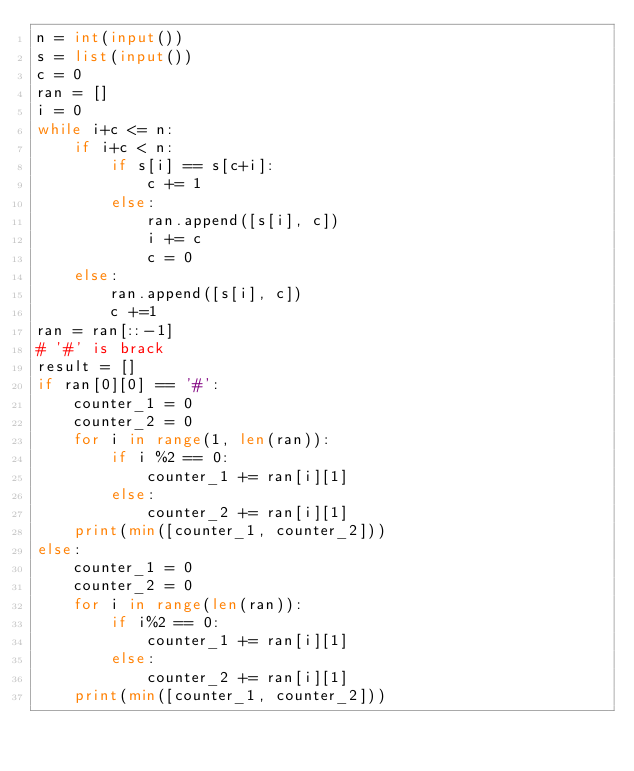Convert code to text. <code><loc_0><loc_0><loc_500><loc_500><_Python_>n = int(input())
s = list(input())
c = 0
ran = []
i = 0
while i+c <= n:
    if i+c < n:
        if s[i] == s[c+i]:
            c += 1
        else:
            ran.append([s[i], c])
            i += c
            c = 0
    else:
        ran.append([s[i], c])
        c +=1
ran = ran[::-1]
# '#' is brack
result = []
if ran[0][0] == '#':
    counter_1 = 0
    counter_2 = 0
    for i in range(1, len(ran)):
        if i %2 == 0:
            counter_1 += ran[i][1]
        else:
            counter_2 += ran[i][1]
    print(min([counter_1, counter_2]))
else:
    counter_1 = 0
    counter_2 = 0
    for i in range(len(ran)):
        if i%2 == 0:
            counter_1 += ran[i][1]
        else:
            counter_2 += ran[i][1]
    print(min([counter_1, counter_2]))</code> 